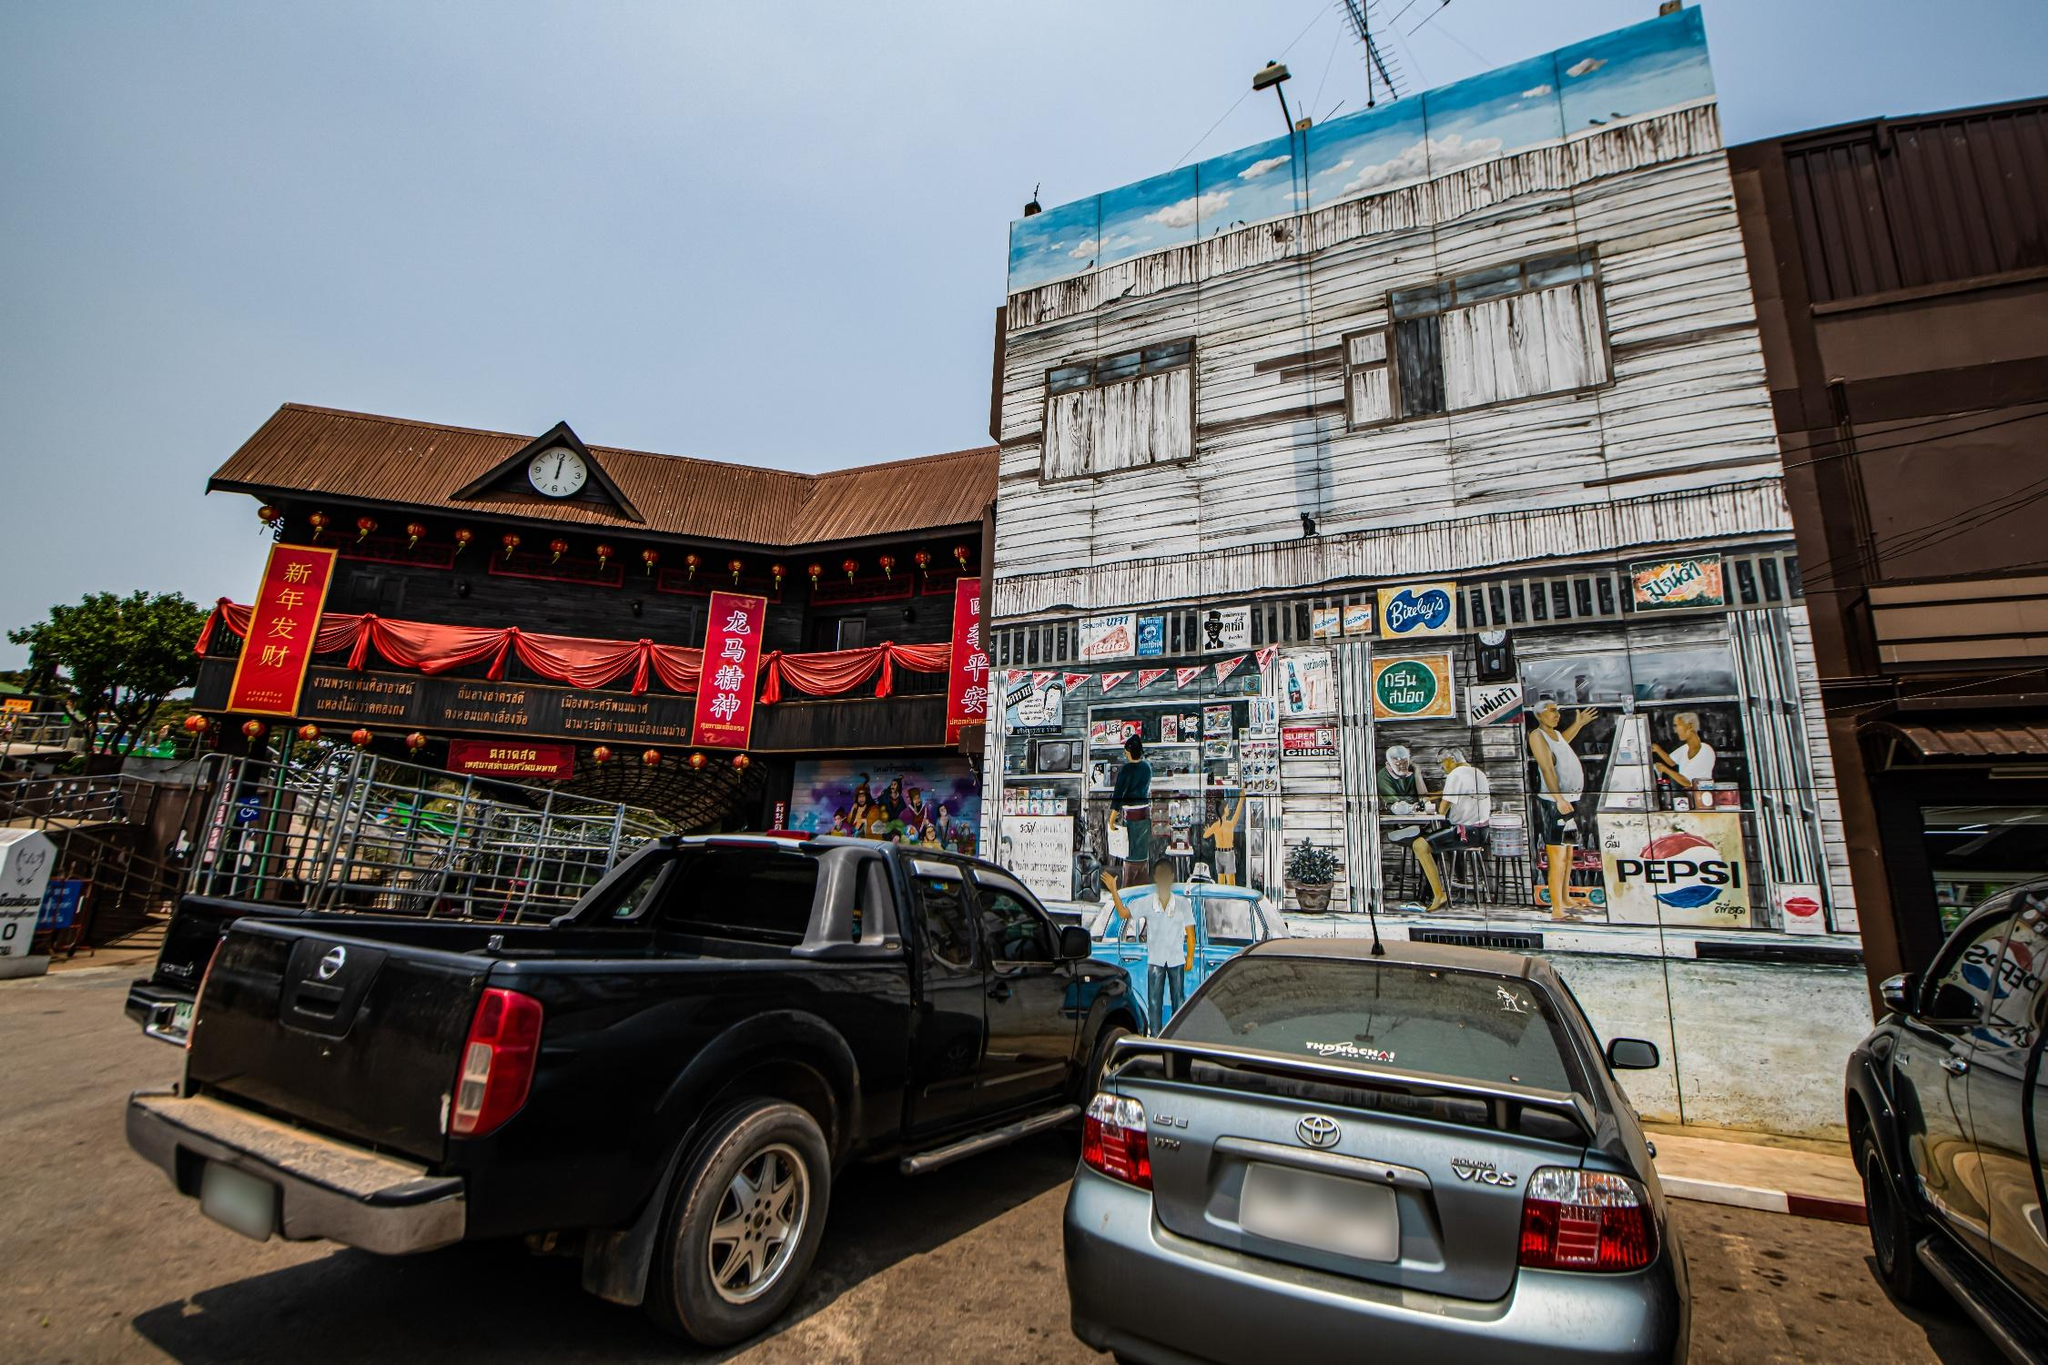Can you elaborate on the elements of the picture provided? The image vividly depicts a bustling street scene in Thailand. Two main vehicles, a black pickup truck and a silver Toyota sedan, are parked on the street, hinting at the daily life and mobility in the area. The view prominently features diverse architectural styles: on the left, a traditional building adorned with red banners that suggest a festive or significant cultural event, possibly a Chinese festival given the text on the banners. This contrasts with the adjacent building, which showcases a faded facade with a commercial mural that includes a Pepsi logo, reflecting global commercial influences. Above this, a makeshift blue tarp suggests pragmatic adaptations to the local climate. The street itself invites curiosity about its daily rhythm and cultural interplay, framed by a clear sky and lush greenery in the background, hinting at the scenic natural surroundings typical of the area. 